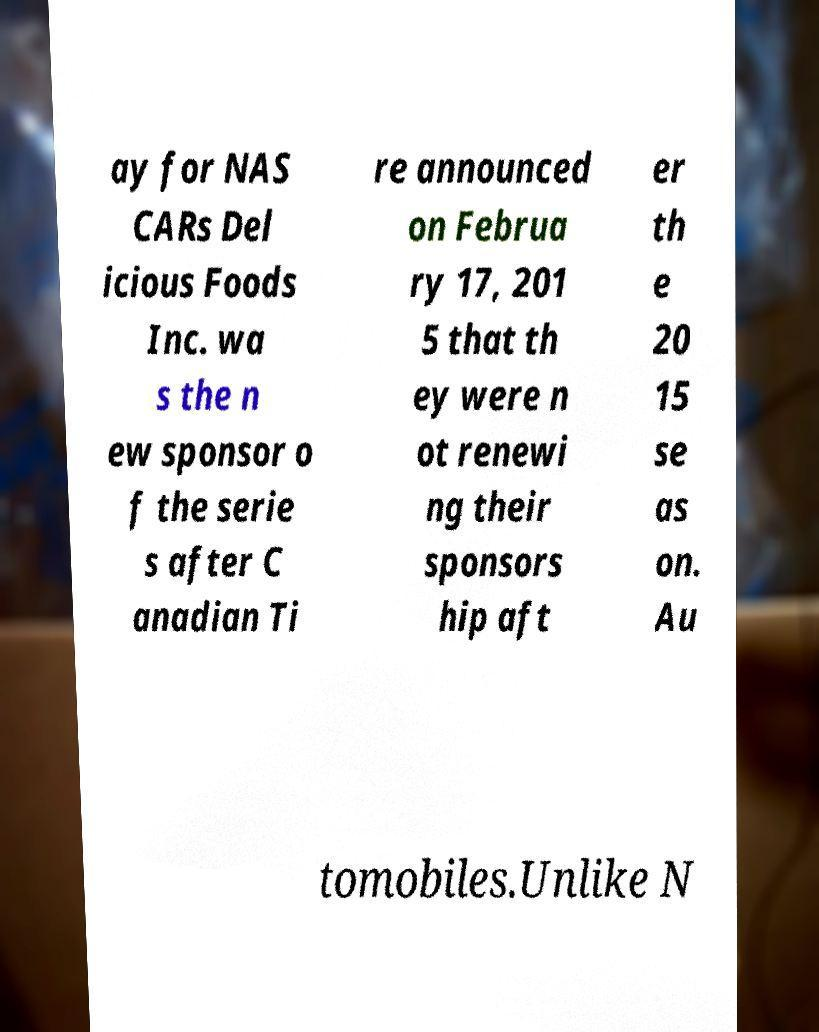There's text embedded in this image that I need extracted. Can you transcribe it verbatim? ay for NAS CARs Del icious Foods Inc. wa s the n ew sponsor o f the serie s after C anadian Ti re announced on Februa ry 17, 201 5 that th ey were n ot renewi ng their sponsors hip aft er th e 20 15 se as on. Au tomobiles.Unlike N 